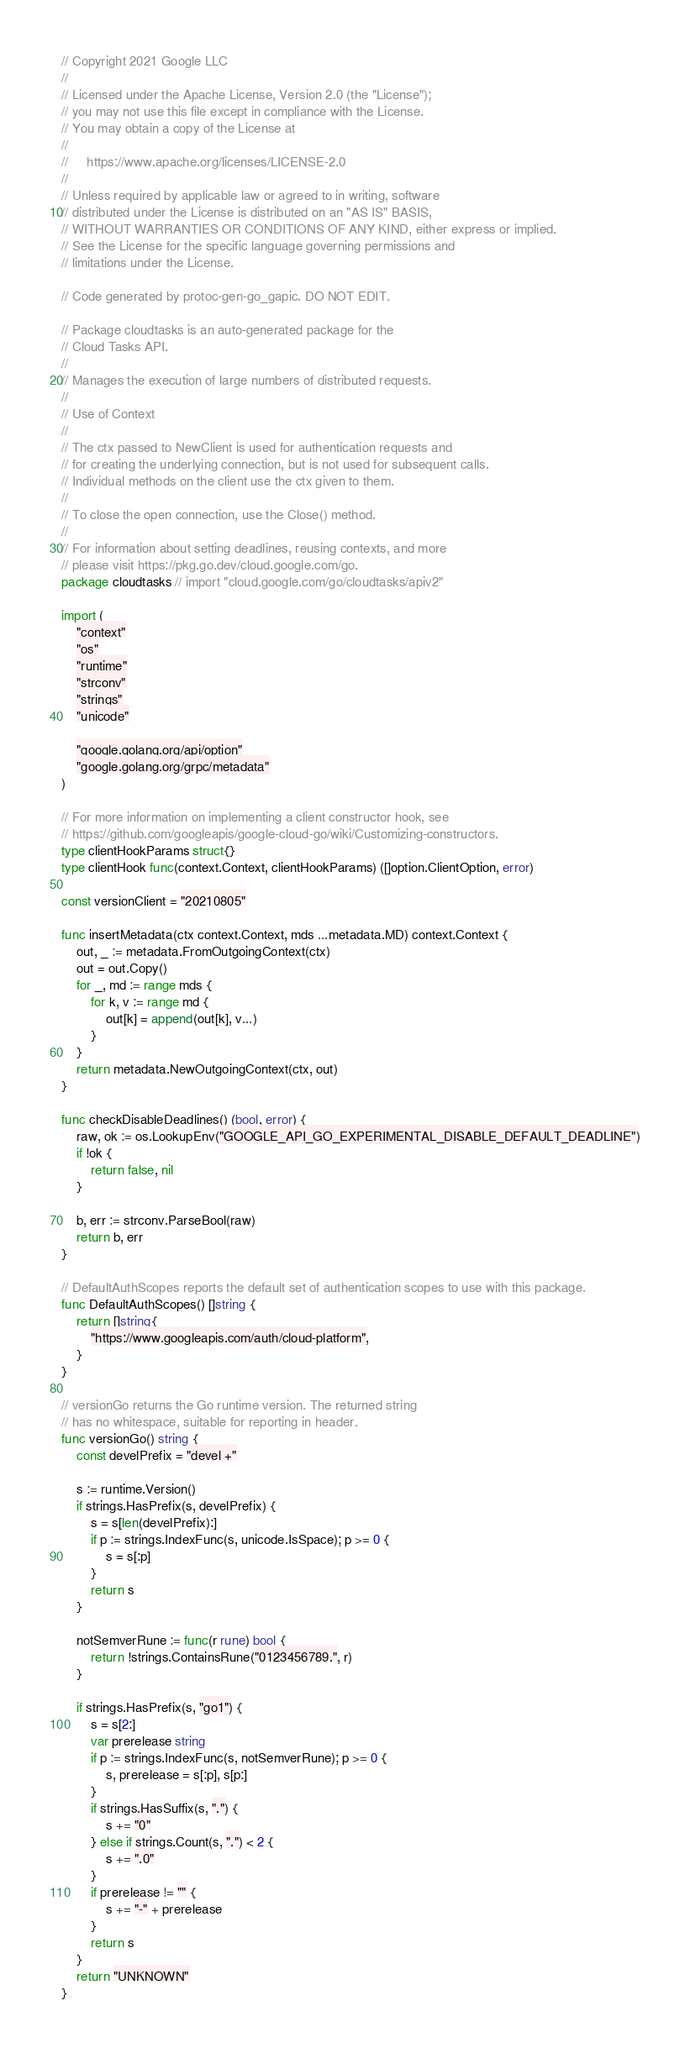Convert code to text. <code><loc_0><loc_0><loc_500><loc_500><_Go_>// Copyright 2021 Google LLC
//
// Licensed under the Apache License, Version 2.0 (the "License");
// you may not use this file except in compliance with the License.
// You may obtain a copy of the License at
//
//     https://www.apache.org/licenses/LICENSE-2.0
//
// Unless required by applicable law or agreed to in writing, software
// distributed under the License is distributed on an "AS IS" BASIS,
// WITHOUT WARRANTIES OR CONDITIONS OF ANY KIND, either express or implied.
// See the License for the specific language governing permissions and
// limitations under the License.

// Code generated by protoc-gen-go_gapic. DO NOT EDIT.

// Package cloudtasks is an auto-generated package for the
// Cloud Tasks API.
//
// Manages the execution of large numbers of distributed requests.
//
// Use of Context
//
// The ctx passed to NewClient is used for authentication requests and
// for creating the underlying connection, but is not used for subsequent calls.
// Individual methods on the client use the ctx given to them.
//
// To close the open connection, use the Close() method.
//
// For information about setting deadlines, reusing contexts, and more
// please visit https://pkg.go.dev/cloud.google.com/go.
package cloudtasks // import "cloud.google.com/go/cloudtasks/apiv2"

import (
	"context"
	"os"
	"runtime"
	"strconv"
	"strings"
	"unicode"

	"google.golang.org/api/option"
	"google.golang.org/grpc/metadata"
)

// For more information on implementing a client constructor hook, see
// https://github.com/googleapis/google-cloud-go/wiki/Customizing-constructors.
type clientHookParams struct{}
type clientHook func(context.Context, clientHookParams) ([]option.ClientOption, error)

const versionClient = "20210805"

func insertMetadata(ctx context.Context, mds ...metadata.MD) context.Context {
	out, _ := metadata.FromOutgoingContext(ctx)
	out = out.Copy()
	for _, md := range mds {
		for k, v := range md {
			out[k] = append(out[k], v...)
		}
	}
	return metadata.NewOutgoingContext(ctx, out)
}

func checkDisableDeadlines() (bool, error) {
	raw, ok := os.LookupEnv("GOOGLE_API_GO_EXPERIMENTAL_DISABLE_DEFAULT_DEADLINE")
	if !ok {
		return false, nil
	}

	b, err := strconv.ParseBool(raw)
	return b, err
}

// DefaultAuthScopes reports the default set of authentication scopes to use with this package.
func DefaultAuthScopes() []string {
	return []string{
		"https://www.googleapis.com/auth/cloud-platform",
	}
}

// versionGo returns the Go runtime version. The returned string
// has no whitespace, suitable for reporting in header.
func versionGo() string {
	const develPrefix = "devel +"

	s := runtime.Version()
	if strings.HasPrefix(s, develPrefix) {
		s = s[len(develPrefix):]
		if p := strings.IndexFunc(s, unicode.IsSpace); p >= 0 {
			s = s[:p]
		}
		return s
	}

	notSemverRune := func(r rune) bool {
		return !strings.ContainsRune("0123456789.", r)
	}

	if strings.HasPrefix(s, "go1") {
		s = s[2:]
		var prerelease string
		if p := strings.IndexFunc(s, notSemverRune); p >= 0 {
			s, prerelease = s[:p], s[p:]
		}
		if strings.HasSuffix(s, ".") {
			s += "0"
		} else if strings.Count(s, ".") < 2 {
			s += ".0"
		}
		if prerelease != "" {
			s += "-" + prerelease
		}
		return s
	}
	return "UNKNOWN"
}
</code> 